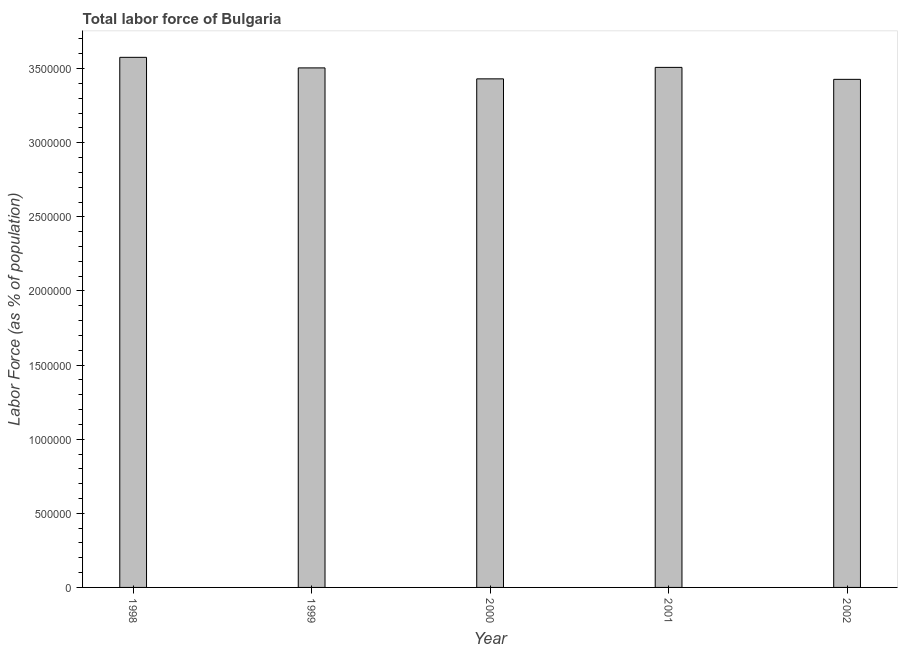Does the graph contain any zero values?
Provide a short and direct response. No. Does the graph contain grids?
Provide a short and direct response. No. What is the title of the graph?
Your answer should be compact. Total labor force of Bulgaria. What is the label or title of the X-axis?
Your response must be concise. Year. What is the label or title of the Y-axis?
Provide a short and direct response. Labor Force (as % of population). What is the total labor force in 2002?
Give a very brief answer. 3.43e+06. Across all years, what is the maximum total labor force?
Your response must be concise. 3.58e+06. Across all years, what is the minimum total labor force?
Provide a short and direct response. 3.43e+06. In which year was the total labor force maximum?
Your response must be concise. 1998. What is the sum of the total labor force?
Keep it short and to the point. 1.74e+07. What is the difference between the total labor force in 1998 and 1999?
Offer a terse response. 7.13e+04. What is the average total labor force per year?
Offer a very short reply. 3.49e+06. What is the median total labor force?
Provide a short and direct response. 3.51e+06. Do a majority of the years between 1999 and 2000 (inclusive) have total labor force greater than 200000 %?
Your response must be concise. Yes. Is the total labor force in 1998 less than that in 1999?
Keep it short and to the point. No. What is the difference between the highest and the second highest total labor force?
Ensure brevity in your answer.  6.78e+04. Is the sum of the total labor force in 2001 and 2002 greater than the maximum total labor force across all years?
Your answer should be compact. Yes. What is the difference between the highest and the lowest total labor force?
Provide a short and direct response. 1.49e+05. In how many years, is the total labor force greater than the average total labor force taken over all years?
Your answer should be very brief. 3. How many bars are there?
Provide a short and direct response. 5. Are all the bars in the graph horizontal?
Provide a short and direct response. No. Are the values on the major ticks of Y-axis written in scientific E-notation?
Your answer should be very brief. No. What is the Labor Force (as % of population) of 1998?
Ensure brevity in your answer.  3.58e+06. What is the Labor Force (as % of population) of 1999?
Your answer should be compact. 3.51e+06. What is the Labor Force (as % of population) in 2000?
Your response must be concise. 3.43e+06. What is the Labor Force (as % of population) of 2001?
Ensure brevity in your answer.  3.51e+06. What is the Labor Force (as % of population) of 2002?
Provide a succinct answer. 3.43e+06. What is the difference between the Labor Force (as % of population) in 1998 and 1999?
Provide a succinct answer. 7.13e+04. What is the difference between the Labor Force (as % of population) in 1998 and 2000?
Ensure brevity in your answer.  1.45e+05. What is the difference between the Labor Force (as % of population) in 1998 and 2001?
Provide a succinct answer. 6.78e+04. What is the difference between the Labor Force (as % of population) in 1998 and 2002?
Ensure brevity in your answer.  1.49e+05. What is the difference between the Labor Force (as % of population) in 1999 and 2000?
Give a very brief answer. 7.40e+04. What is the difference between the Labor Force (as % of population) in 1999 and 2001?
Your response must be concise. -3473. What is the difference between the Labor Force (as % of population) in 1999 and 2002?
Make the answer very short. 7.73e+04. What is the difference between the Labor Force (as % of population) in 2000 and 2001?
Make the answer very short. -7.75e+04. What is the difference between the Labor Force (as % of population) in 2000 and 2002?
Provide a short and direct response. 3299. What is the difference between the Labor Force (as % of population) in 2001 and 2002?
Your response must be concise. 8.08e+04. What is the ratio of the Labor Force (as % of population) in 1998 to that in 2000?
Provide a succinct answer. 1.04. What is the ratio of the Labor Force (as % of population) in 1998 to that in 2001?
Offer a terse response. 1.02. What is the ratio of the Labor Force (as % of population) in 1998 to that in 2002?
Make the answer very short. 1.04. What is the ratio of the Labor Force (as % of population) in 1999 to that in 2000?
Offer a very short reply. 1.02. What is the ratio of the Labor Force (as % of population) in 2000 to that in 2002?
Your answer should be compact. 1. 